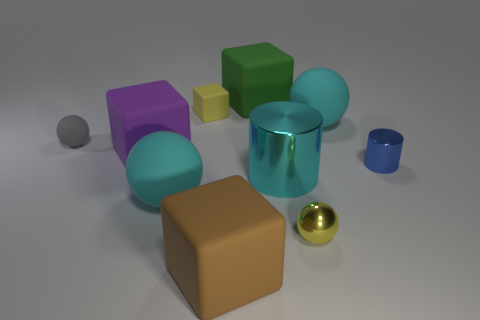Are there any gray objects that have the same material as the yellow sphere?
Offer a terse response. No. What number of objects are either large objects that are left of the big brown object or large metallic cylinders?
Your response must be concise. 3. Are any yellow blocks visible?
Provide a short and direct response. Yes. There is a tiny thing that is on the left side of the tiny blue thing and in front of the large purple matte thing; what is its shape?
Offer a very short reply. Sphere. How big is the cyan rubber thing left of the green matte cube?
Your response must be concise. Large. Does the cylinder to the left of the blue cylinder have the same color as the small cube?
Your answer should be compact. No. How many big green matte things are the same shape as the large purple rubber object?
Your response must be concise. 1. What number of things are either rubber things that are in front of the tiny gray sphere or small metal objects that are in front of the blue thing?
Your answer should be compact. 4. How many cyan things are either large things or tiny matte balls?
Make the answer very short. 3. What is the material of the sphere that is in front of the large metallic object and left of the small yellow ball?
Provide a succinct answer. Rubber. 